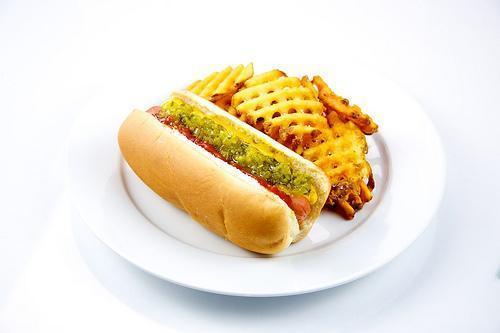How many hotdogs are there?
Give a very brief answer. 1. How many hot dogs are on the plate?
Give a very brief answer. 1. 